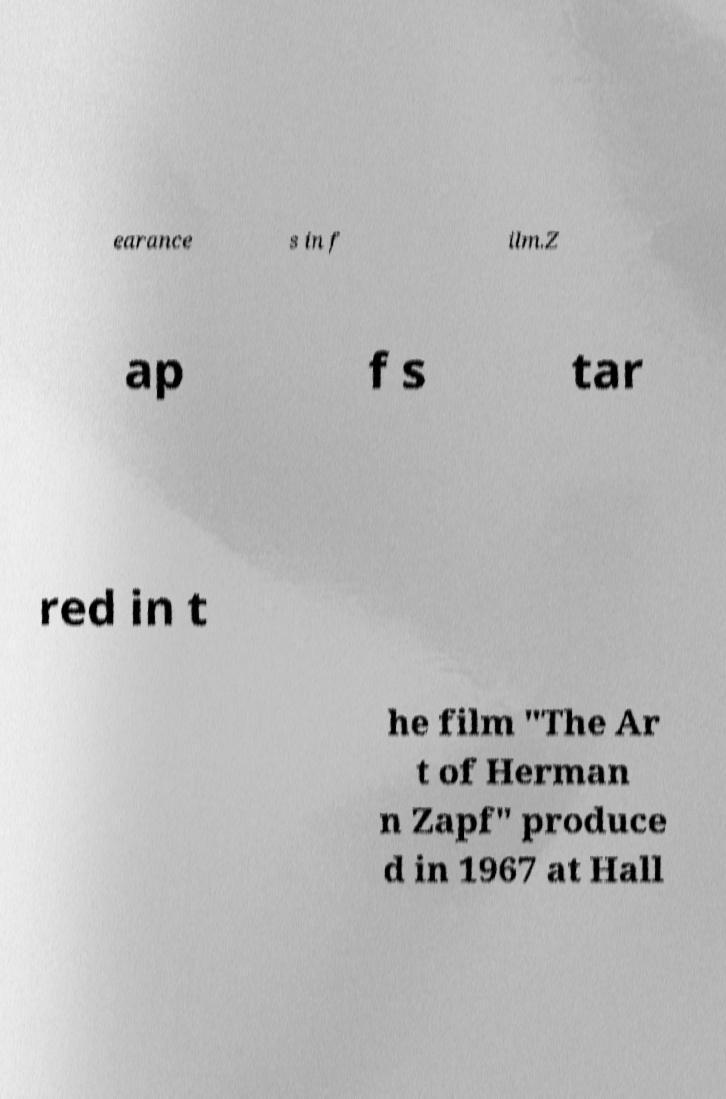There's text embedded in this image that I need extracted. Can you transcribe it verbatim? earance s in f ilm.Z ap f s tar red in t he film "The Ar t of Herman n Zapf" produce d in 1967 at Hall 